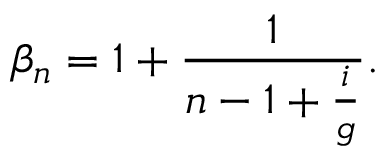<formula> <loc_0><loc_0><loc_500><loc_500>\beta _ { n } = 1 + \frac { 1 } { n - 1 + \frac { i } { g } } .</formula> 